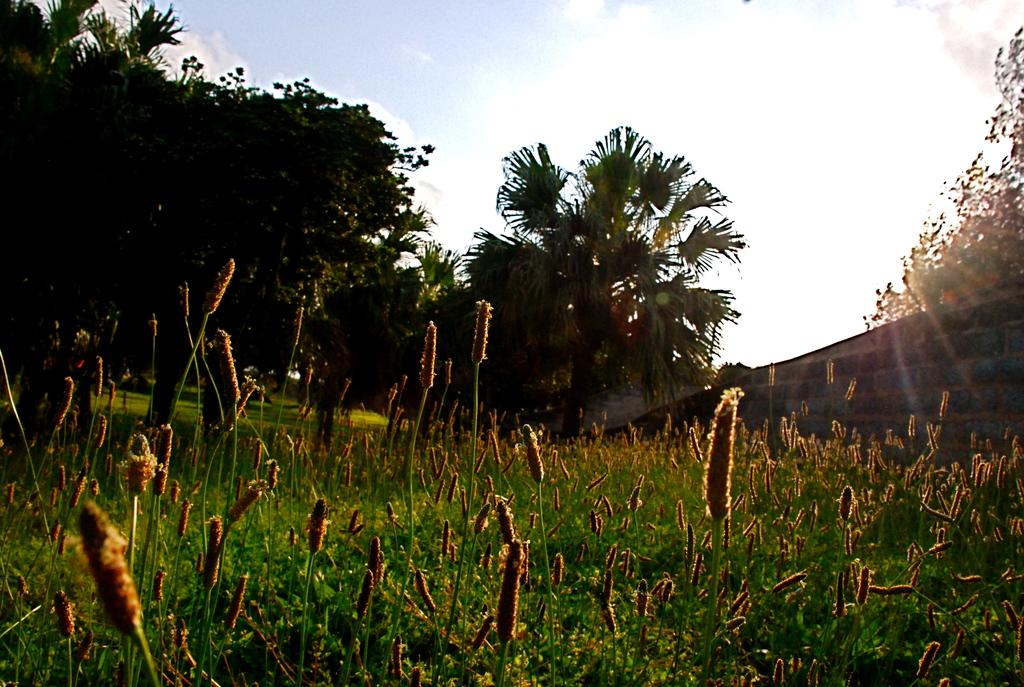What is the main feature in the center of the image? There is grass in the center of the image. What can be seen in the background of the image? The sky, clouds, trees, grass, and a wall are present in the background of the image. What type of cave can be seen in the image? There is no cave present in the image. Can you tell me how many members are in the committee depicted in the image? There is no committee present in the image. 